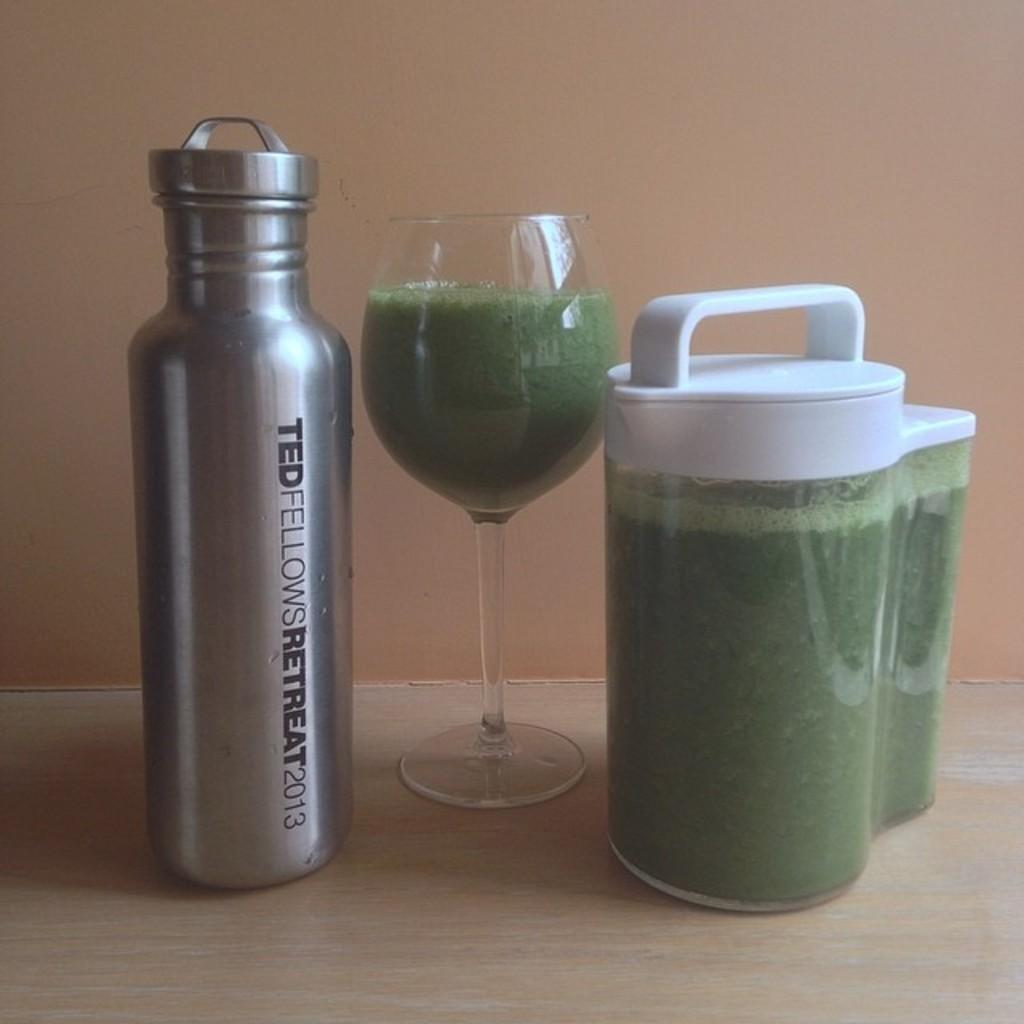<image>
Describe the image concisely. A Ted Fellows Retreat water bottle is next to a green drink. 